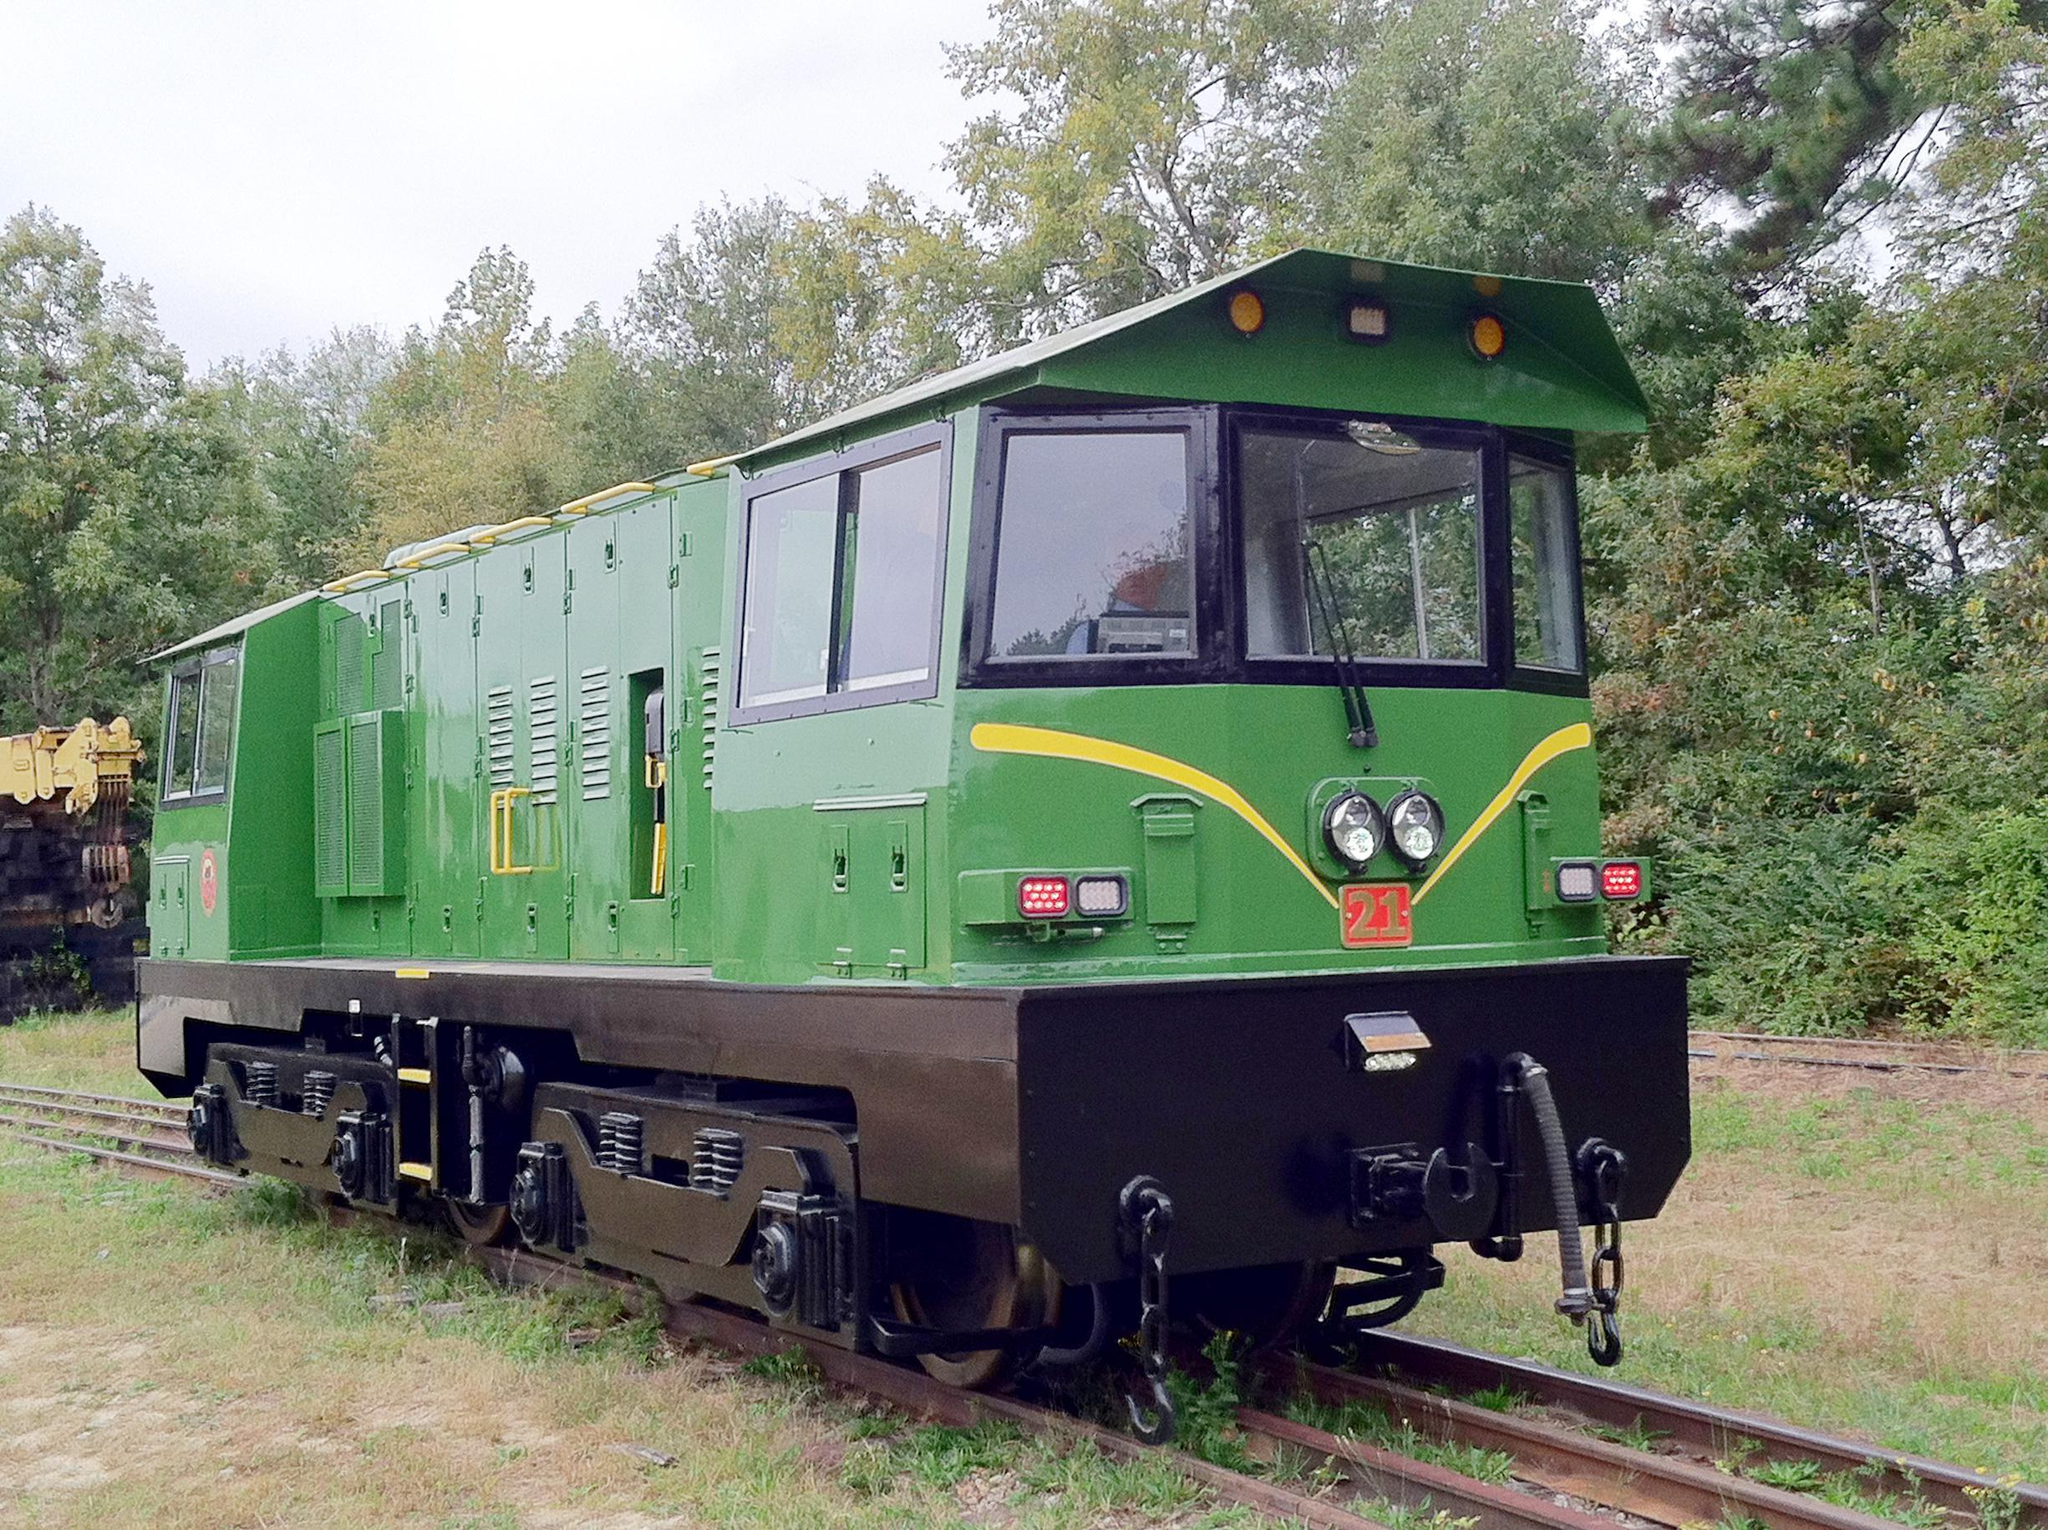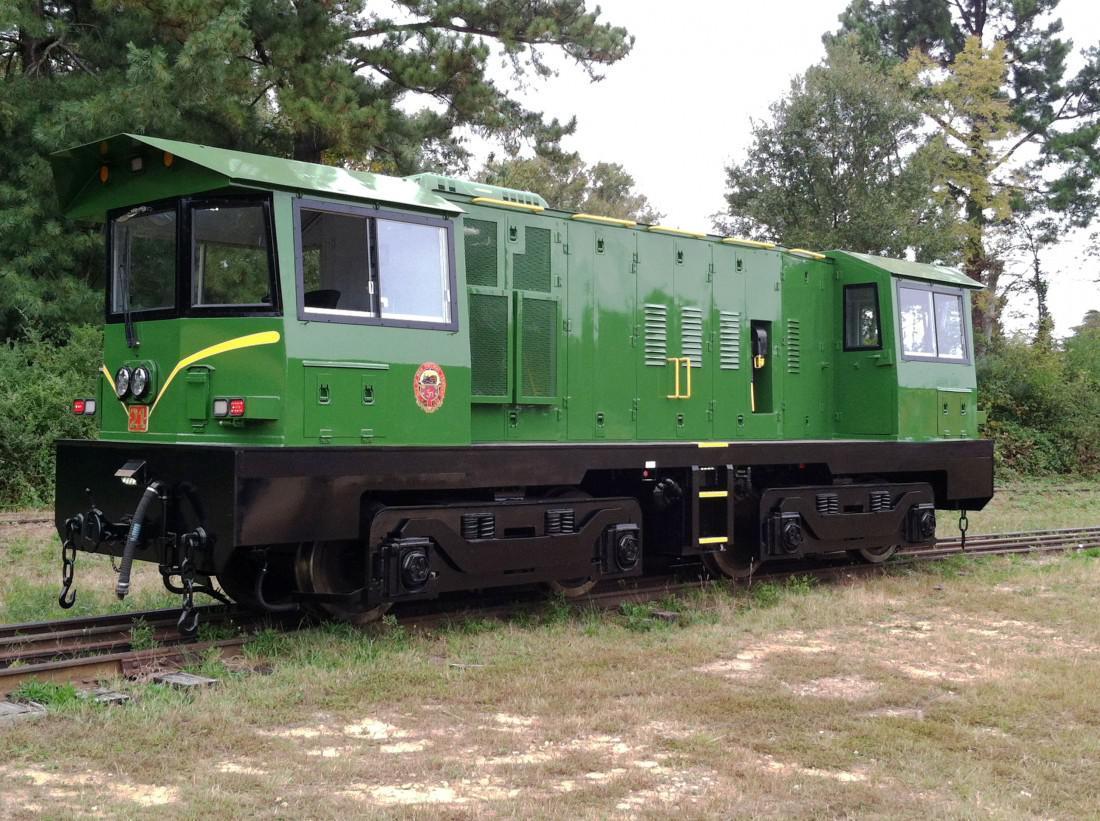The first image is the image on the left, the second image is the image on the right. Given the left and right images, does the statement "All the trains depicted feature green coloring." hold true? Answer yes or no. Yes. 